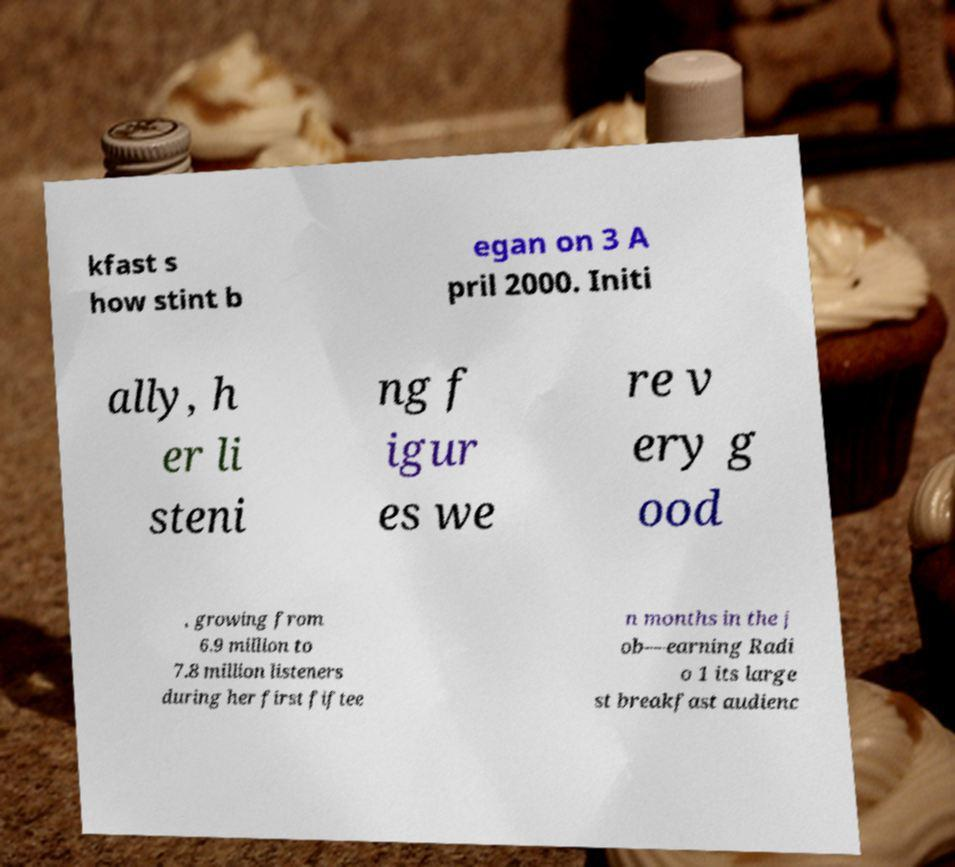Could you assist in decoding the text presented in this image and type it out clearly? kfast s how stint b egan on 3 A pril 2000. Initi ally, h er li steni ng f igur es we re v ery g ood , growing from 6.9 million to 7.8 million listeners during her first fiftee n months in the j ob—earning Radi o 1 its large st breakfast audienc 